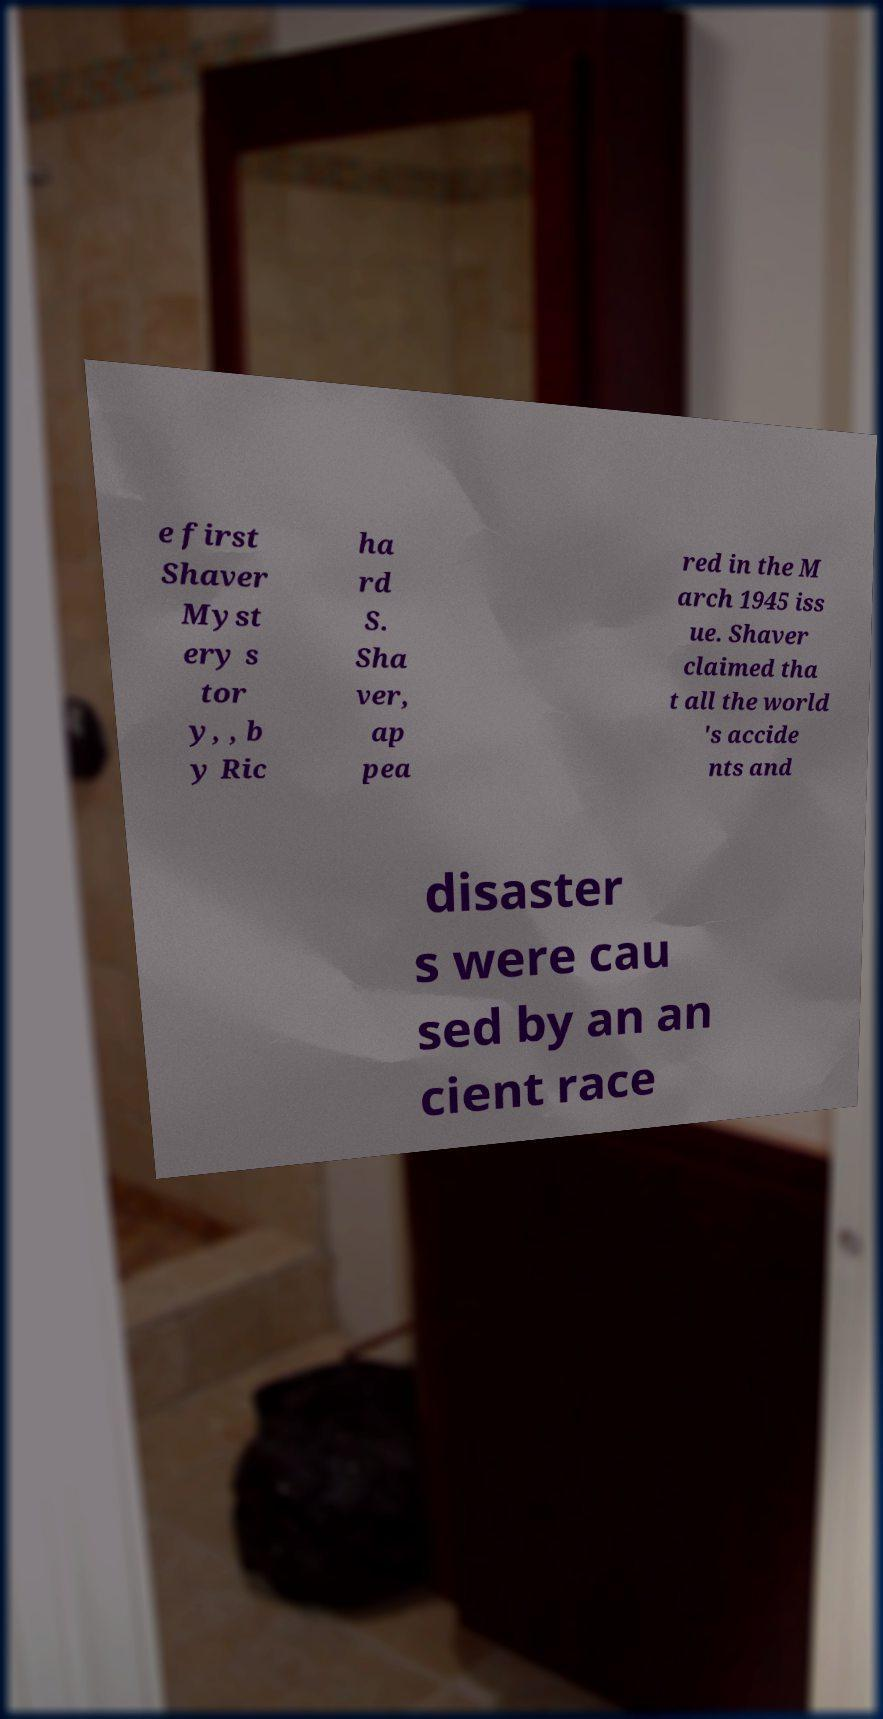For documentation purposes, I need the text within this image transcribed. Could you provide that? e first Shaver Myst ery s tor y, , b y Ric ha rd S. Sha ver, ap pea red in the M arch 1945 iss ue. Shaver claimed tha t all the world 's accide nts and disaster s were cau sed by an an cient race 